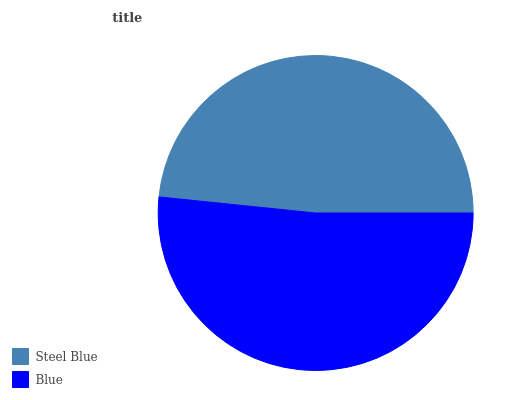Is Steel Blue the minimum?
Answer yes or no. Yes. Is Blue the maximum?
Answer yes or no. Yes. Is Blue the minimum?
Answer yes or no. No. Is Blue greater than Steel Blue?
Answer yes or no. Yes. Is Steel Blue less than Blue?
Answer yes or no. Yes. Is Steel Blue greater than Blue?
Answer yes or no. No. Is Blue less than Steel Blue?
Answer yes or no. No. Is Blue the high median?
Answer yes or no. Yes. Is Steel Blue the low median?
Answer yes or no. Yes. Is Steel Blue the high median?
Answer yes or no. No. Is Blue the low median?
Answer yes or no. No. 